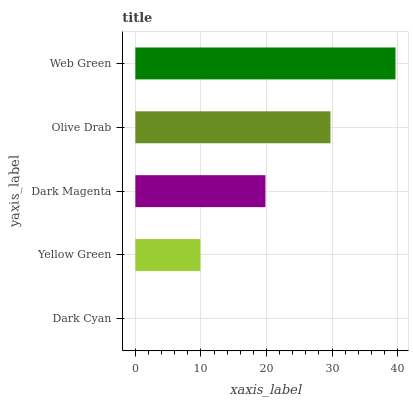Is Dark Cyan the minimum?
Answer yes or no. Yes. Is Web Green the maximum?
Answer yes or no. Yes. Is Yellow Green the minimum?
Answer yes or no. No. Is Yellow Green the maximum?
Answer yes or no. No. Is Yellow Green greater than Dark Cyan?
Answer yes or no. Yes. Is Dark Cyan less than Yellow Green?
Answer yes or no. Yes. Is Dark Cyan greater than Yellow Green?
Answer yes or no. No. Is Yellow Green less than Dark Cyan?
Answer yes or no. No. Is Dark Magenta the high median?
Answer yes or no. Yes. Is Dark Magenta the low median?
Answer yes or no. Yes. Is Yellow Green the high median?
Answer yes or no. No. Is Web Green the low median?
Answer yes or no. No. 